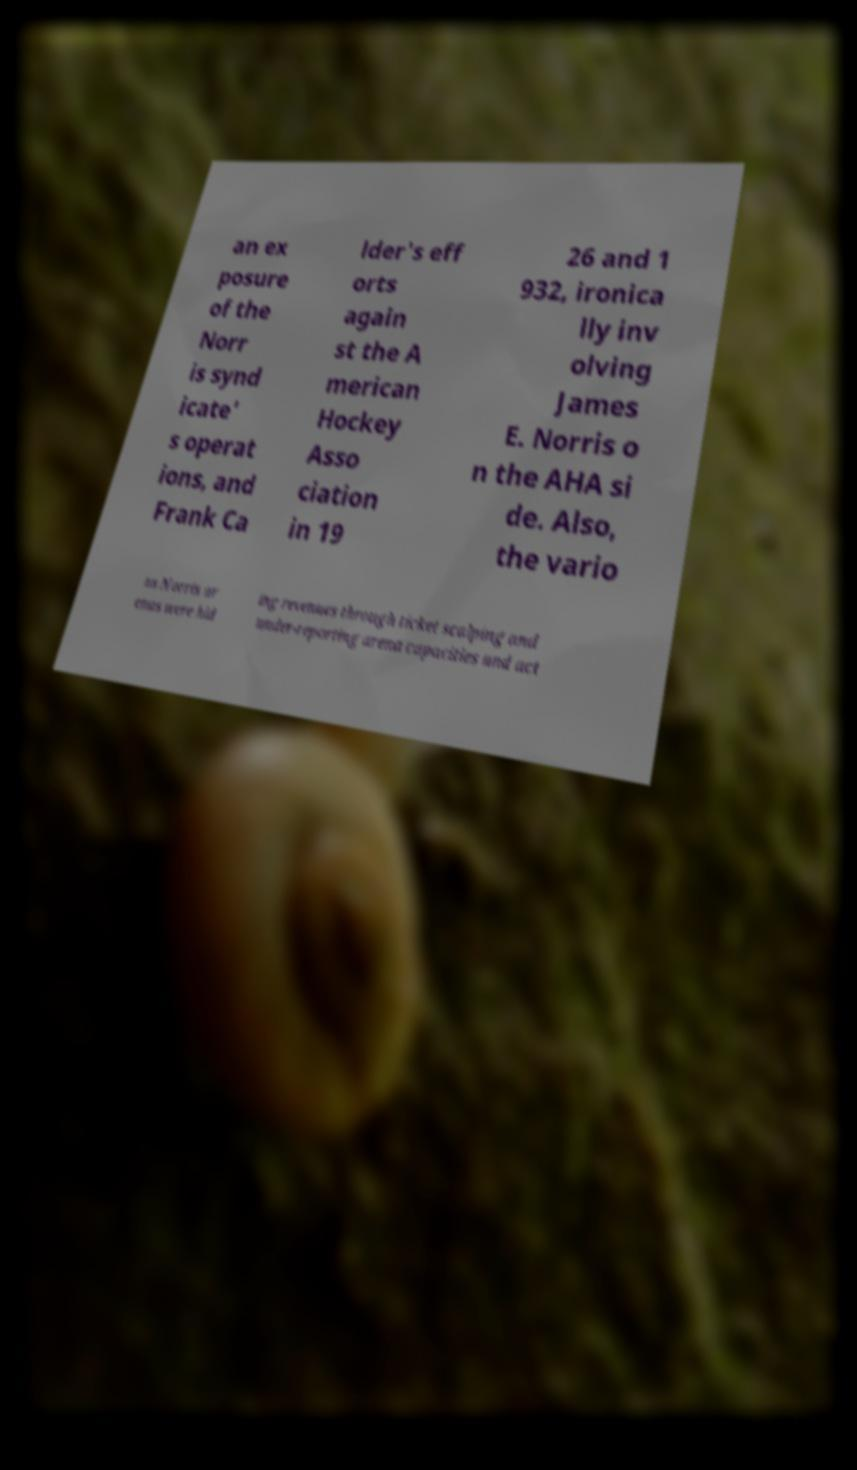For documentation purposes, I need the text within this image transcribed. Could you provide that? an ex posure of the Norr is synd icate' s operat ions, and Frank Ca lder's eff orts again st the A merican Hockey Asso ciation in 19 26 and 1 932, ironica lly inv olving James E. Norris o n the AHA si de. Also, the vario us Norris ar enas were hid ing revenues through ticket scalping and under-reporting arena capacities and act 